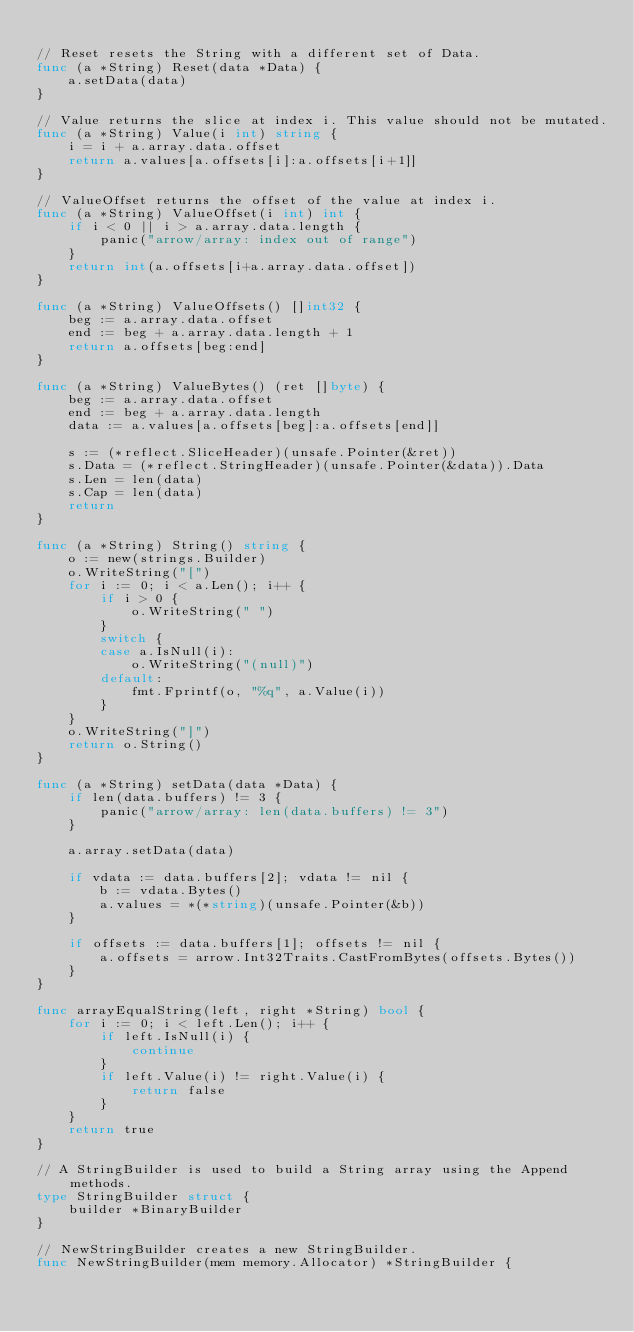Convert code to text. <code><loc_0><loc_0><loc_500><loc_500><_Go_>
// Reset resets the String with a different set of Data.
func (a *String) Reset(data *Data) {
	a.setData(data)
}

// Value returns the slice at index i. This value should not be mutated.
func (a *String) Value(i int) string {
	i = i + a.array.data.offset
	return a.values[a.offsets[i]:a.offsets[i+1]]
}

// ValueOffset returns the offset of the value at index i.
func (a *String) ValueOffset(i int) int {
	if i < 0 || i > a.array.data.length {
		panic("arrow/array: index out of range")
	}
	return int(a.offsets[i+a.array.data.offset])
}

func (a *String) ValueOffsets() []int32 {
	beg := a.array.data.offset
	end := beg + a.array.data.length + 1
	return a.offsets[beg:end]
}

func (a *String) ValueBytes() (ret []byte) {
	beg := a.array.data.offset
	end := beg + a.array.data.length
	data := a.values[a.offsets[beg]:a.offsets[end]]

	s := (*reflect.SliceHeader)(unsafe.Pointer(&ret))
	s.Data = (*reflect.StringHeader)(unsafe.Pointer(&data)).Data
	s.Len = len(data)
	s.Cap = len(data)
	return
}

func (a *String) String() string {
	o := new(strings.Builder)
	o.WriteString("[")
	for i := 0; i < a.Len(); i++ {
		if i > 0 {
			o.WriteString(" ")
		}
		switch {
		case a.IsNull(i):
			o.WriteString("(null)")
		default:
			fmt.Fprintf(o, "%q", a.Value(i))
		}
	}
	o.WriteString("]")
	return o.String()
}

func (a *String) setData(data *Data) {
	if len(data.buffers) != 3 {
		panic("arrow/array: len(data.buffers) != 3")
	}

	a.array.setData(data)

	if vdata := data.buffers[2]; vdata != nil {
		b := vdata.Bytes()
		a.values = *(*string)(unsafe.Pointer(&b))
	}

	if offsets := data.buffers[1]; offsets != nil {
		a.offsets = arrow.Int32Traits.CastFromBytes(offsets.Bytes())
	}
}

func arrayEqualString(left, right *String) bool {
	for i := 0; i < left.Len(); i++ {
		if left.IsNull(i) {
			continue
		}
		if left.Value(i) != right.Value(i) {
			return false
		}
	}
	return true
}

// A StringBuilder is used to build a String array using the Append methods.
type StringBuilder struct {
	builder *BinaryBuilder
}

// NewStringBuilder creates a new StringBuilder.
func NewStringBuilder(mem memory.Allocator) *StringBuilder {</code> 